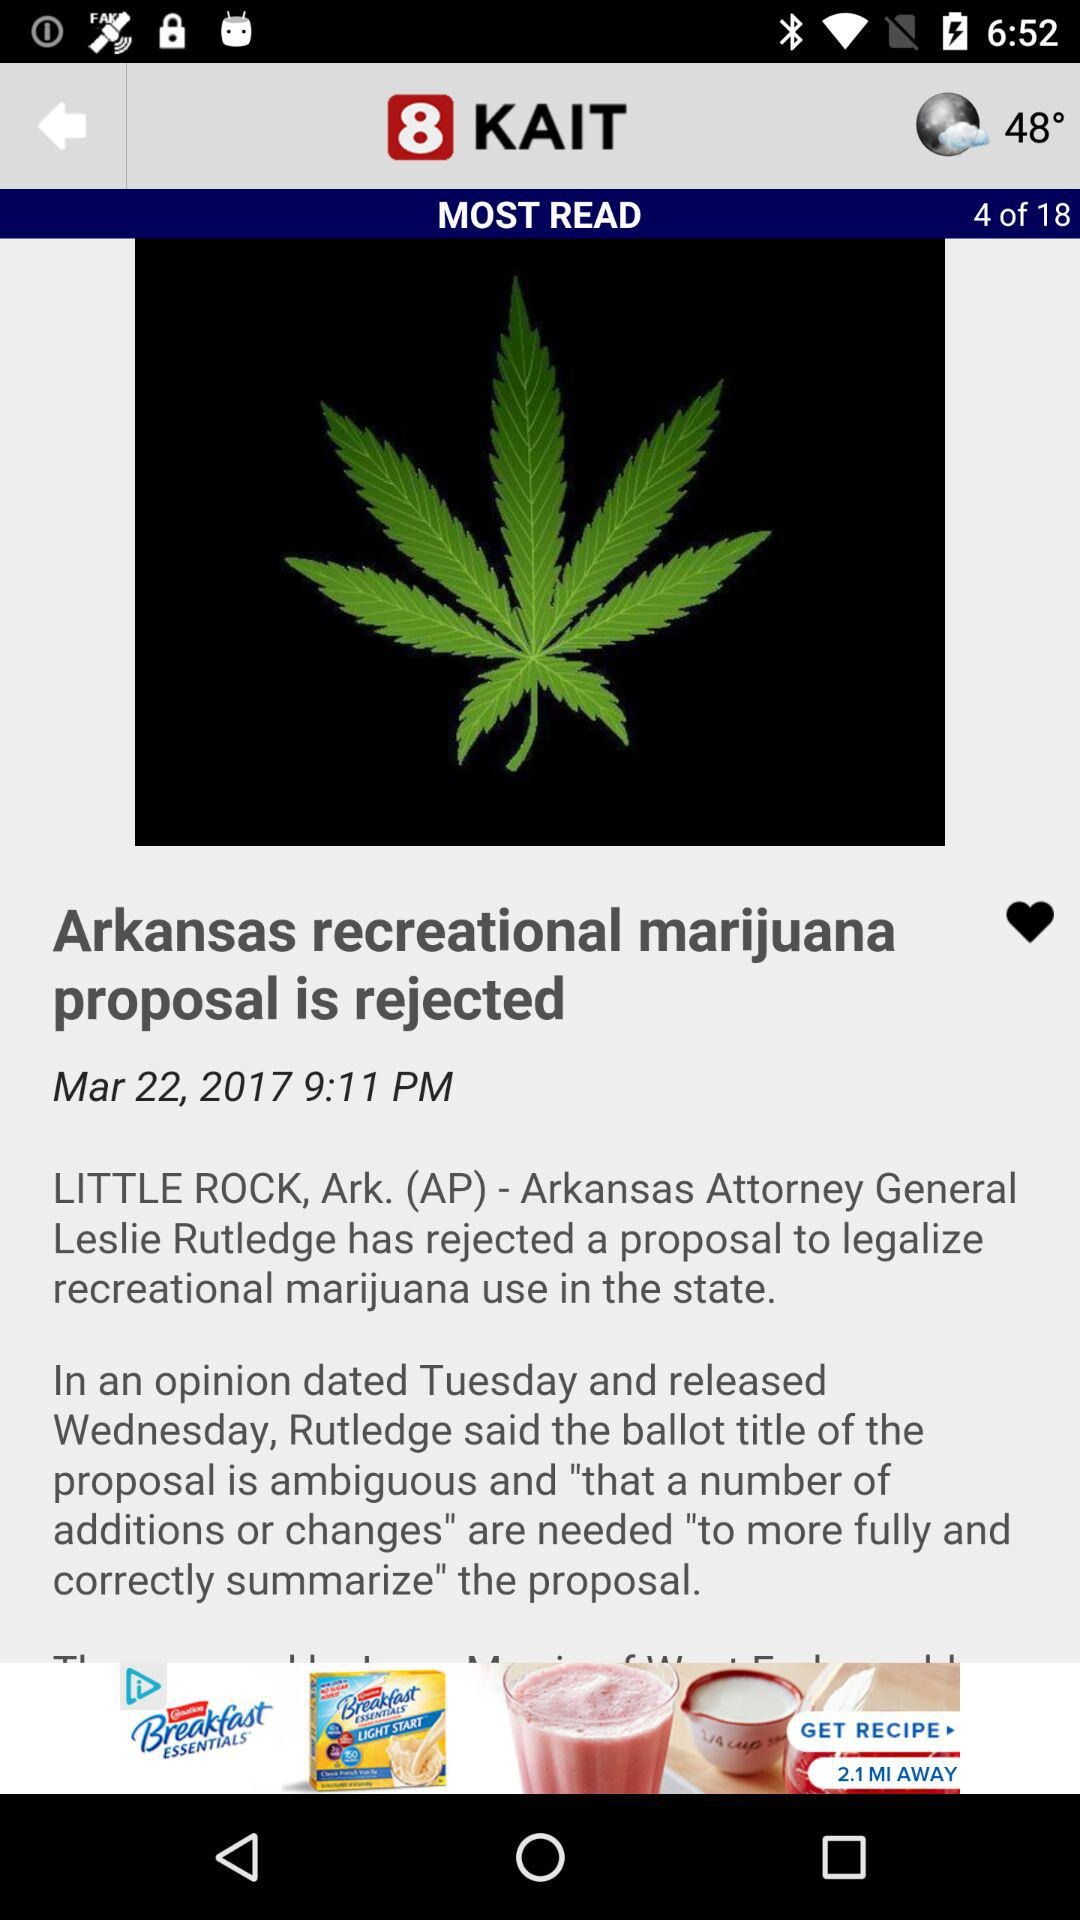Who rejected the proposal to legalise recreational marijuana? The proposal was rejected by Arkansas Attorney General Leslie Rutledge. 